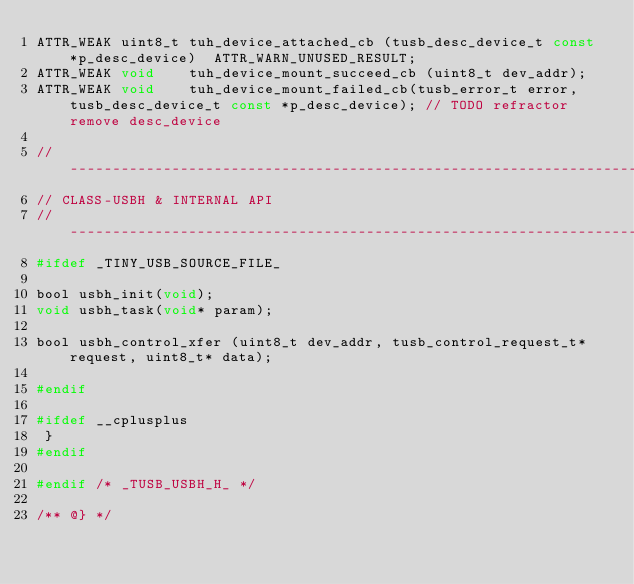Convert code to text. <code><loc_0><loc_0><loc_500><loc_500><_C_>ATTR_WEAK uint8_t tuh_device_attached_cb (tusb_desc_device_t const *p_desc_device)  ATTR_WARN_UNUSED_RESULT;
ATTR_WEAK void    tuh_device_mount_succeed_cb (uint8_t dev_addr);
ATTR_WEAK void    tuh_device_mount_failed_cb(tusb_error_t error, tusb_desc_device_t const *p_desc_device); // TODO refractor remove desc_device

//--------------------------------------------------------------------+
// CLASS-USBH & INTERNAL API
//--------------------------------------------------------------------+
#ifdef _TINY_USB_SOURCE_FILE_

bool usbh_init(void);
void usbh_task(void* param);

bool usbh_control_xfer (uint8_t dev_addr, tusb_control_request_t* request, uint8_t* data);

#endif

#ifdef __cplusplus
 }
#endif

#endif /* _TUSB_USBH_H_ */

/** @} */
</code> 